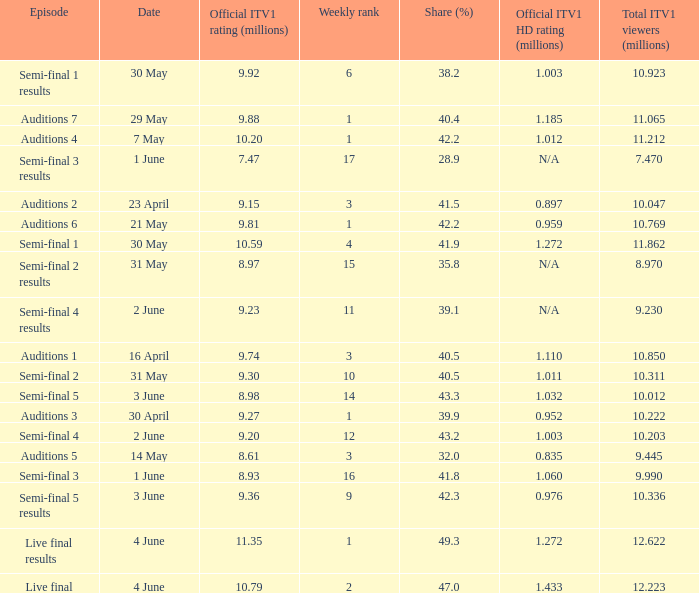What was the official ITV1 HD rating in millions for the episode that had an official ITV1 rating of 8.98 million? 1.032. 